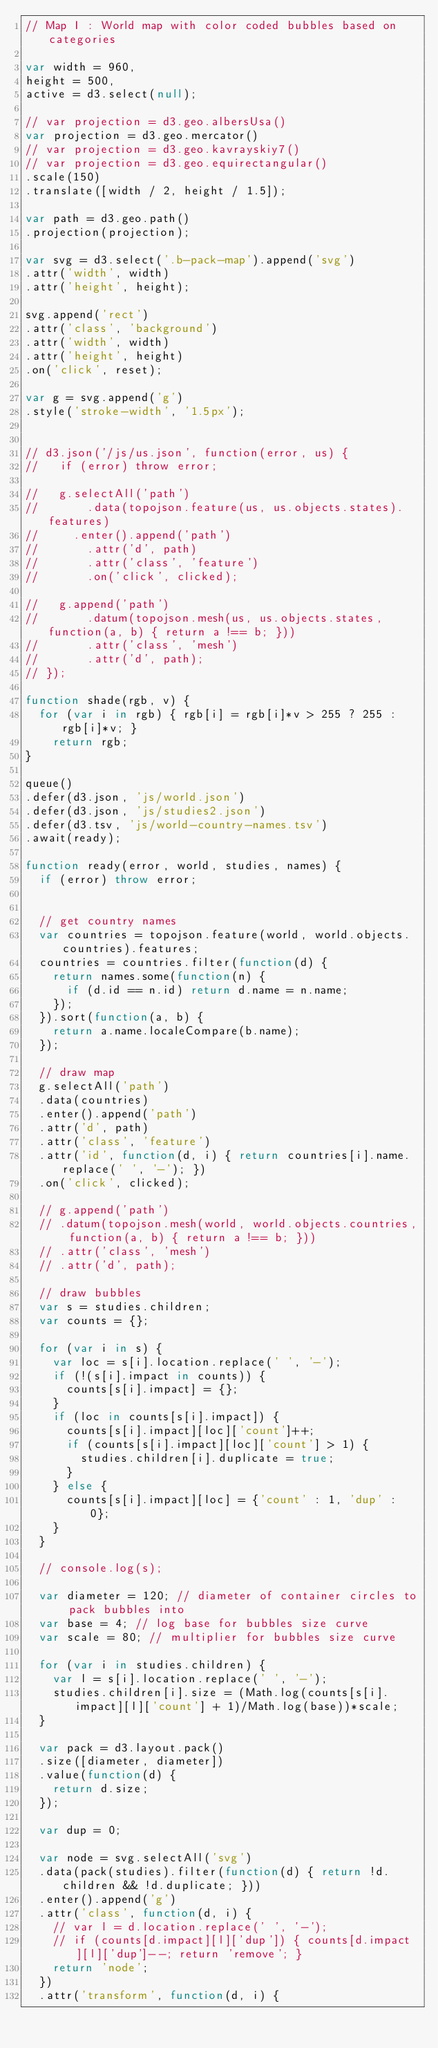Convert code to text. <code><loc_0><loc_0><loc_500><loc_500><_JavaScript_>// Map I : World map with color coded bubbles based on categories

var width = 960,
height = 500,
active = d3.select(null);

// var projection = d3.geo.albersUsa()
var projection = d3.geo.mercator()
// var projection = d3.geo.kavrayskiy7()
// var projection = d3.geo.equirectangular()
.scale(150)
.translate([width / 2, height / 1.5]);

var path = d3.geo.path()
.projection(projection);

var svg = d3.select('.b-pack-map').append('svg')
.attr('width', width)
.attr('height', height);

svg.append('rect')
.attr('class', 'background')
.attr('width', width)
.attr('height', height)
.on('click', reset);

var g = svg.append('g')
.style('stroke-width', '1.5px');


// d3.json('/js/us.json', function(error, us) {
//   if (error) throw error;

//   g.selectAll('path')
//       .data(topojson.feature(us, us.objects.states).features)
//     .enter().append('path')
//       .attr('d', path)
//       .attr('class', 'feature')
//       .on('click', clicked);

//   g.append('path')
//       .datum(topojson.mesh(us, us.objects.states, function(a, b) { return a !== b; }))
//       .attr('class', 'mesh')
//       .attr('d', path);
// });

function shade(rgb, v) {
  for (var i in rgb) { rgb[i] = rgb[i]*v > 255 ? 255 : rgb[i]*v; }
    return rgb;
}

queue()
.defer(d3.json, 'js/world.json')
.defer(d3.json, 'js/studies2.json')
.defer(d3.tsv, 'js/world-country-names.tsv')
.await(ready);

function ready(error, world, studies, names) {
  if (error) throw error;


  // get country names
  var countries = topojson.feature(world, world.objects.countries).features;
  countries = countries.filter(function(d) {
    return names.some(function(n) {
      if (d.id == n.id) return d.name = n.name;
    });
  }).sort(function(a, b) {
    return a.name.localeCompare(b.name);
  });

  // draw map
  g.selectAll('path')
  .data(countries)
  .enter().append('path')
  .attr('d', path)
  .attr('class', 'feature')
  .attr('id', function(d, i) { return countries[i].name.replace(' ', '-'); })
  .on('click', clicked);

  // g.append('path')
  // .datum(topojson.mesh(world, world.objects.countries, function(a, b) { return a !== b; }))
  // .attr('class', 'mesh')
  // .attr('d', path);

  // draw bubbles
  var s = studies.children;
  var counts = {};

  for (var i in s) {
    var loc = s[i].location.replace(' ', '-');
    if (!(s[i].impact in counts)) {
      counts[s[i].impact] = {};
    }
    if (loc in counts[s[i].impact]) {
      counts[s[i].impact][loc]['count']++;
      if (counts[s[i].impact][loc]['count'] > 1) {
        studies.children[i].duplicate = true;
      }
    } else {
      counts[s[i].impact][loc] = {'count' : 1, 'dup' : 0};
    }
  }

  // console.log(s);

  var diameter = 120; // diameter of container circles to pack bubbles into
  var base = 4; // log base for bubbles size curve
  var scale = 80; // multiplier for bubbles size curve

  for (var i in studies.children) {
    var l = s[i].location.replace(' ', '-');
    studies.children[i].size = (Math.log(counts[s[i].impact][l]['count'] + 1)/Math.log(base))*scale;
  }

  var pack = d3.layout.pack()
  .size([diameter, diameter])
  .value(function(d) {
    return d.size;
  });

  var dup = 0;

  var node = svg.selectAll('svg')
  .data(pack(studies).filter(function(d) { return !d.children && !d.duplicate; }))
  .enter().append('g')
  .attr('class', function(d, i) {
    // var l = d.location.replace(' ', '-');
    // if (counts[d.impact][l]['dup']) { counts[d.impact][l]['dup']--; return 'remove'; }
    return 'node';
  })
  .attr('transform', function(d, i) {</code> 